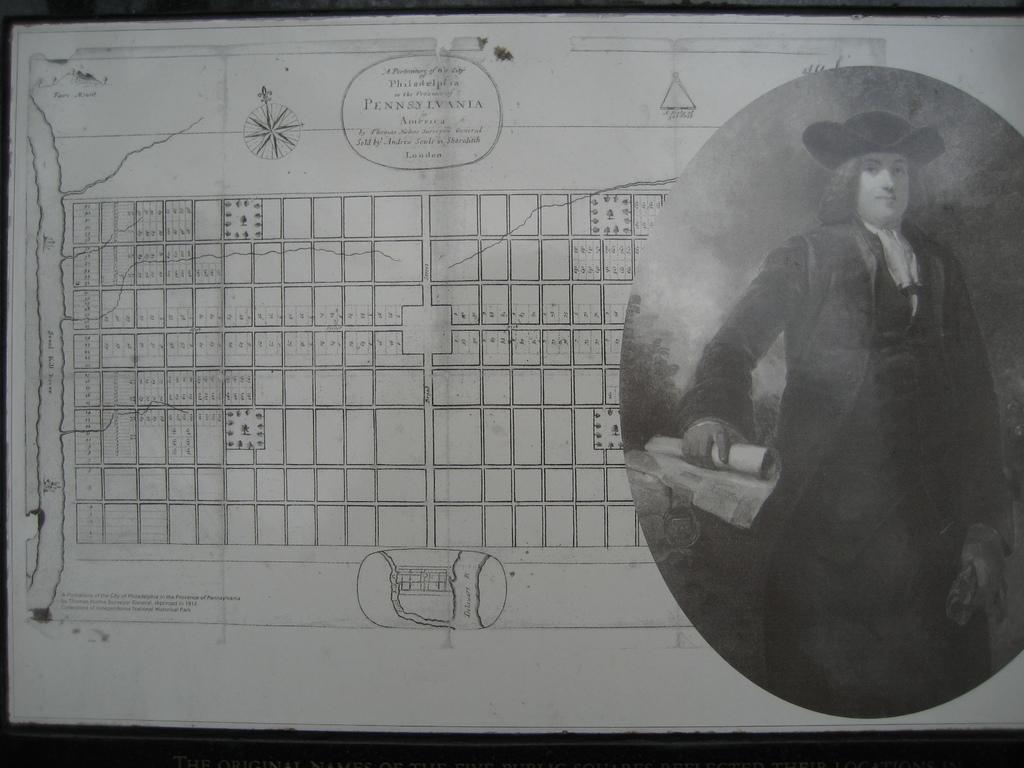Can you describe this image briefly? In the image we can see there is a chart on which there is a man standing and he is wearing formal suit and hat. There is a map on the chart and the image is in black and white colour. 